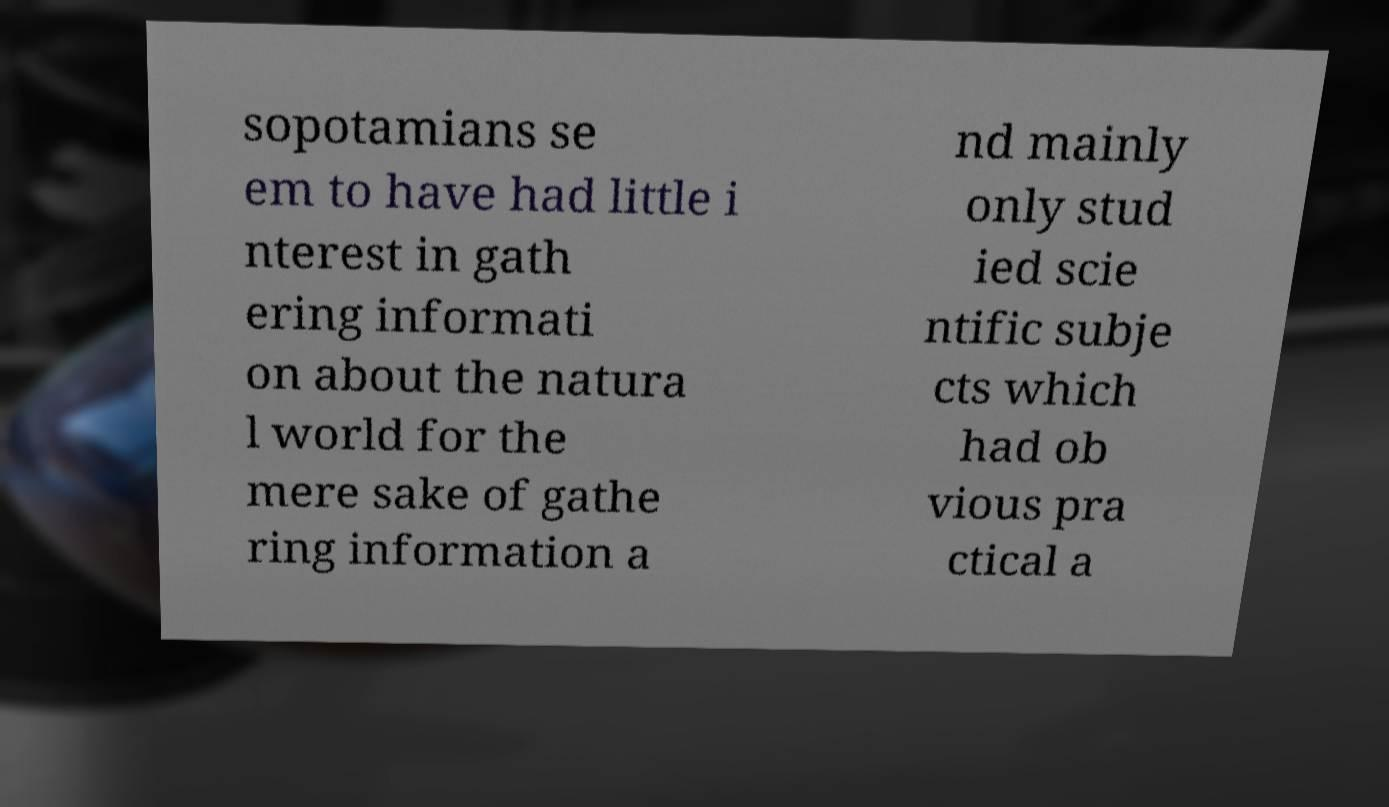What messages or text are displayed in this image? I need them in a readable, typed format. sopotamians se em to have had little i nterest in gath ering informati on about the natura l world for the mere sake of gathe ring information a nd mainly only stud ied scie ntific subje cts which had ob vious pra ctical a 